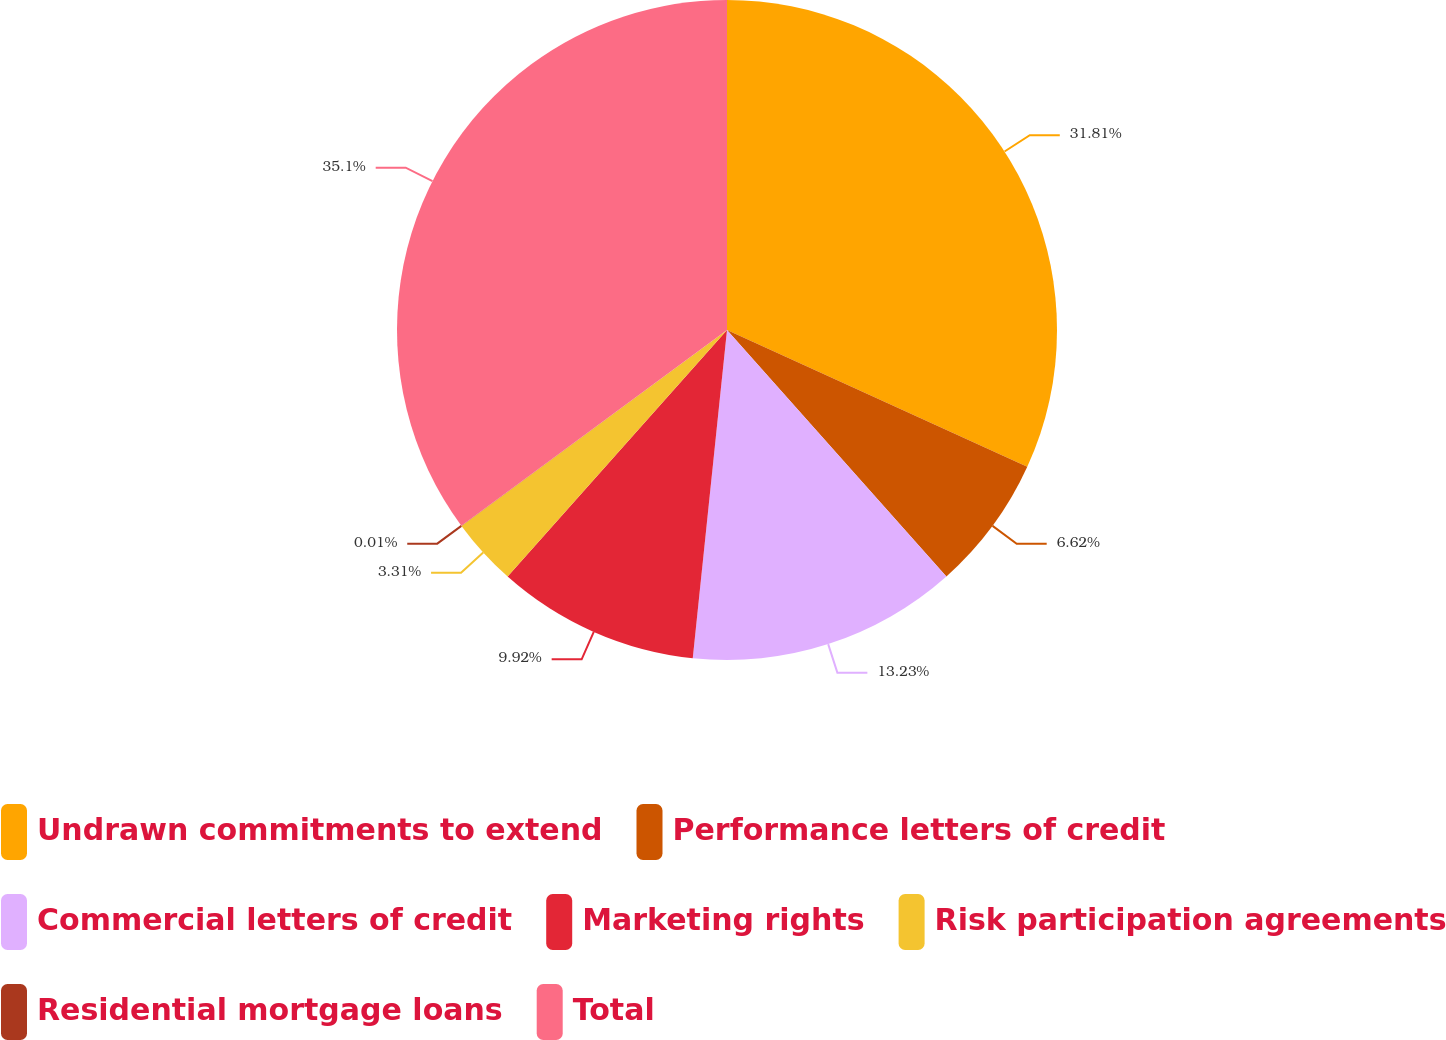<chart> <loc_0><loc_0><loc_500><loc_500><pie_chart><fcel>Undrawn commitments to extend<fcel>Performance letters of credit<fcel>Commercial letters of credit<fcel>Marketing rights<fcel>Risk participation agreements<fcel>Residential mortgage loans<fcel>Total<nl><fcel>31.81%<fcel>6.62%<fcel>13.23%<fcel>9.92%<fcel>3.31%<fcel>0.01%<fcel>35.11%<nl></chart> 